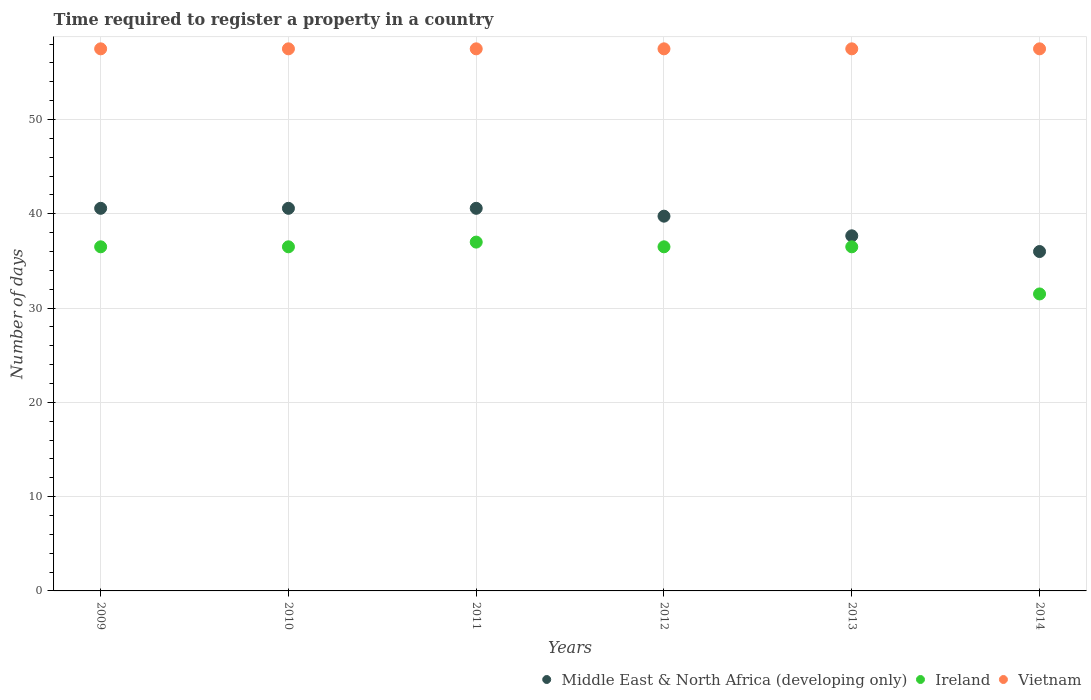Across all years, what is the maximum number of days required to register a property in Vietnam?
Your answer should be very brief. 57.5. Across all years, what is the minimum number of days required to register a property in Ireland?
Your answer should be very brief. 31.5. In which year was the number of days required to register a property in Middle East & North Africa (developing only) minimum?
Keep it short and to the point. 2014. What is the total number of days required to register a property in Vietnam in the graph?
Your answer should be very brief. 345. What is the difference between the number of days required to register a property in Middle East & North Africa (developing only) in 2009 and that in 2012?
Provide a succinct answer. 0.83. What is the difference between the number of days required to register a property in Ireland in 2011 and the number of days required to register a property in Middle East & North Africa (developing only) in 2014?
Ensure brevity in your answer.  1. What is the average number of days required to register a property in Middle East & North Africa (developing only) per year?
Your response must be concise. 39.19. In the year 2011, what is the difference between the number of days required to register a property in Vietnam and number of days required to register a property in Middle East & North Africa (developing only)?
Offer a very short reply. 16.92. Is the number of days required to register a property in Vietnam in 2009 less than that in 2013?
Provide a succinct answer. No. What is the difference between the highest and the second highest number of days required to register a property in Vietnam?
Give a very brief answer. 0. In how many years, is the number of days required to register a property in Ireland greater than the average number of days required to register a property in Ireland taken over all years?
Give a very brief answer. 5. Is the sum of the number of days required to register a property in Ireland in 2011 and 2013 greater than the maximum number of days required to register a property in Middle East & North Africa (developing only) across all years?
Offer a terse response. Yes. Is it the case that in every year, the sum of the number of days required to register a property in Ireland and number of days required to register a property in Vietnam  is greater than the number of days required to register a property in Middle East & North Africa (developing only)?
Give a very brief answer. Yes. Is the number of days required to register a property in Vietnam strictly greater than the number of days required to register a property in Middle East & North Africa (developing only) over the years?
Your answer should be very brief. Yes. Is the number of days required to register a property in Middle East & North Africa (developing only) strictly less than the number of days required to register a property in Ireland over the years?
Make the answer very short. No. How many dotlines are there?
Your answer should be compact. 3. How many years are there in the graph?
Make the answer very short. 6. Are the values on the major ticks of Y-axis written in scientific E-notation?
Your response must be concise. No. Does the graph contain any zero values?
Offer a very short reply. No. Where does the legend appear in the graph?
Offer a terse response. Bottom right. How are the legend labels stacked?
Provide a short and direct response. Horizontal. What is the title of the graph?
Provide a succinct answer. Time required to register a property in a country. Does "Indonesia" appear as one of the legend labels in the graph?
Provide a short and direct response. No. What is the label or title of the Y-axis?
Keep it short and to the point. Number of days. What is the Number of days of Middle East & North Africa (developing only) in 2009?
Offer a very short reply. 40.58. What is the Number of days of Ireland in 2009?
Provide a short and direct response. 36.5. What is the Number of days of Vietnam in 2009?
Give a very brief answer. 57.5. What is the Number of days in Middle East & North Africa (developing only) in 2010?
Your answer should be very brief. 40.58. What is the Number of days in Ireland in 2010?
Offer a very short reply. 36.5. What is the Number of days in Vietnam in 2010?
Your response must be concise. 57.5. What is the Number of days in Middle East & North Africa (developing only) in 2011?
Provide a succinct answer. 40.58. What is the Number of days of Ireland in 2011?
Ensure brevity in your answer.  37. What is the Number of days of Vietnam in 2011?
Offer a very short reply. 57.5. What is the Number of days in Middle East & North Africa (developing only) in 2012?
Offer a terse response. 39.75. What is the Number of days in Ireland in 2012?
Make the answer very short. 36.5. What is the Number of days of Vietnam in 2012?
Ensure brevity in your answer.  57.5. What is the Number of days in Middle East & North Africa (developing only) in 2013?
Keep it short and to the point. 37.67. What is the Number of days of Ireland in 2013?
Your response must be concise. 36.5. What is the Number of days in Vietnam in 2013?
Give a very brief answer. 57.5. What is the Number of days of Middle East & North Africa (developing only) in 2014?
Your answer should be compact. 36. What is the Number of days of Ireland in 2014?
Ensure brevity in your answer.  31.5. What is the Number of days in Vietnam in 2014?
Keep it short and to the point. 57.5. Across all years, what is the maximum Number of days in Middle East & North Africa (developing only)?
Offer a very short reply. 40.58. Across all years, what is the maximum Number of days of Vietnam?
Make the answer very short. 57.5. Across all years, what is the minimum Number of days of Middle East & North Africa (developing only)?
Your answer should be compact. 36. Across all years, what is the minimum Number of days in Ireland?
Your answer should be compact. 31.5. Across all years, what is the minimum Number of days in Vietnam?
Make the answer very short. 57.5. What is the total Number of days in Middle East & North Africa (developing only) in the graph?
Make the answer very short. 235.17. What is the total Number of days in Ireland in the graph?
Your answer should be compact. 214.5. What is the total Number of days in Vietnam in the graph?
Offer a very short reply. 345. What is the difference between the Number of days of Ireland in 2009 and that in 2010?
Your answer should be compact. 0. What is the difference between the Number of days of Vietnam in 2009 and that in 2010?
Provide a succinct answer. 0. What is the difference between the Number of days in Middle East & North Africa (developing only) in 2009 and that in 2011?
Your answer should be very brief. 0. What is the difference between the Number of days of Ireland in 2009 and that in 2011?
Make the answer very short. -0.5. What is the difference between the Number of days in Vietnam in 2009 and that in 2011?
Your answer should be compact. 0. What is the difference between the Number of days in Middle East & North Africa (developing only) in 2009 and that in 2012?
Offer a terse response. 0.83. What is the difference between the Number of days of Ireland in 2009 and that in 2012?
Keep it short and to the point. 0. What is the difference between the Number of days of Middle East & North Africa (developing only) in 2009 and that in 2013?
Offer a very short reply. 2.92. What is the difference between the Number of days of Ireland in 2009 and that in 2013?
Offer a terse response. 0. What is the difference between the Number of days in Middle East & North Africa (developing only) in 2009 and that in 2014?
Keep it short and to the point. 4.58. What is the difference between the Number of days in Ireland in 2009 and that in 2014?
Ensure brevity in your answer.  5. What is the difference between the Number of days of Vietnam in 2009 and that in 2014?
Provide a short and direct response. 0. What is the difference between the Number of days in Ireland in 2010 and that in 2011?
Your response must be concise. -0.5. What is the difference between the Number of days of Middle East & North Africa (developing only) in 2010 and that in 2012?
Provide a short and direct response. 0.83. What is the difference between the Number of days of Middle East & North Africa (developing only) in 2010 and that in 2013?
Offer a terse response. 2.92. What is the difference between the Number of days of Vietnam in 2010 and that in 2013?
Provide a succinct answer. 0. What is the difference between the Number of days in Middle East & North Africa (developing only) in 2010 and that in 2014?
Offer a very short reply. 4.58. What is the difference between the Number of days of Ireland in 2010 and that in 2014?
Make the answer very short. 5. What is the difference between the Number of days of Ireland in 2011 and that in 2012?
Your answer should be very brief. 0.5. What is the difference between the Number of days in Middle East & North Africa (developing only) in 2011 and that in 2013?
Your answer should be compact. 2.92. What is the difference between the Number of days in Ireland in 2011 and that in 2013?
Your response must be concise. 0.5. What is the difference between the Number of days in Middle East & North Africa (developing only) in 2011 and that in 2014?
Your answer should be compact. 4.58. What is the difference between the Number of days in Vietnam in 2011 and that in 2014?
Give a very brief answer. 0. What is the difference between the Number of days of Middle East & North Africa (developing only) in 2012 and that in 2013?
Keep it short and to the point. 2.08. What is the difference between the Number of days of Middle East & North Africa (developing only) in 2012 and that in 2014?
Your answer should be very brief. 3.75. What is the difference between the Number of days of Ireland in 2012 and that in 2014?
Provide a succinct answer. 5. What is the difference between the Number of days of Vietnam in 2012 and that in 2014?
Ensure brevity in your answer.  0. What is the difference between the Number of days of Vietnam in 2013 and that in 2014?
Provide a succinct answer. 0. What is the difference between the Number of days in Middle East & North Africa (developing only) in 2009 and the Number of days in Ireland in 2010?
Your answer should be very brief. 4.08. What is the difference between the Number of days of Middle East & North Africa (developing only) in 2009 and the Number of days of Vietnam in 2010?
Your answer should be very brief. -16.92. What is the difference between the Number of days of Ireland in 2009 and the Number of days of Vietnam in 2010?
Provide a short and direct response. -21. What is the difference between the Number of days of Middle East & North Africa (developing only) in 2009 and the Number of days of Ireland in 2011?
Your answer should be very brief. 3.58. What is the difference between the Number of days of Middle East & North Africa (developing only) in 2009 and the Number of days of Vietnam in 2011?
Provide a short and direct response. -16.92. What is the difference between the Number of days of Middle East & North Africa (developing only) in 2009 and the Number of days of Ireland in 2012?
Give a very brief answer. 4.08. What is the difference between the Number of days in Middle East & North Africa (developing only) in 2009 and the Number of days in Vietnam in 2012?
Ensure brevity in your answer.  -16.92. What is the difference between the Number of days of Middle East & North Africa (developing only) in 2009 and the Number of days of Ireland in 2013?
Provide a short and direct response. 4.08. What is the difference between the Number of days in Middle East & North Africa (developing only) in 2009 and the Number of days in Vietnam in 2013?
Your response must be concise. -16.92. What is the difference between the Number of days in Ireland in 2009 and the Number of days in Vietnam in 2013?
Offer a very short reply. -21. What is the difference between the Number of days of Middle East & North Africa (developing only) in 2009 and the Number of days of Ireland in 2014?
Offer a terse response. 9.08. What is the difference between the Number of days of Middle East & North Africa (developing only) in 2009 and the Number of days of Vietnam in 2014?
Give a very brief answer. -16.92. What is the difference between the Number of days in Ireland in 2009 and the Number of days in Vietnam in 2014?
Your response must be concise. -21. What is the difference between the Number of days of Middle East & North Africa (developing only) in 2010 and the Number of days of Ireland in 2011?
Your response must be concise. 3.58. What is the difference between the Number of days of Middle East & North Africa (developing only) in 2010 and the Number of days of Vietnam in 2011?
Your answer should be compact. -16.92. What is the difference between the Number of days of Middle East & North Africa (developing only) in 2010 and the Number of days of Ireland in 2012?
Your answer should be very brief. 4.08. What is the difference between the Number of days in Middle East & North Africa (developing only) in 2010 and the Number of days in Vietnam in 2012?
Your answer should be compact. -16.92. What is the difference between the Number of days of Middle East & North Africa (developing only) in 2010 and the Number of days of Ireland in 2013?
Give a very brief answer. 4.08. What is the difference between the Number of days of Middle East & North Africa (developing only) in 2010 and the Number of days of Vietnam in 2013?
Make the answer very short. -16.92. What is the difference between the Number of days in Middle East & North Africa (developing only) in 2010 and the Number of days in Ireland in 2014?
Provide a succinct answer. 9.08. What is the difference between the Number of days of Middle East & North Africa (developing only) in 2010 and the Number of days of Vietnam in 2014?
Offer a terse response. -16.92. What is the difference between the Number of days of Middle East & North Africa (developing only) in 2011 and the Number of days of Ireland in 2012?
Ensure brevity in your answer.  4.08. What is the difference between the Number of days in Middle East & North Africa (developing only) in 2011 and the Number of days in Vietnam in 2012?
Offer a terse response. -16.92. What is the difference between the Number of days of Ireland in 2011 and the Number of days of Vietnam in 2012?
Your answer should be very brief. -20.5. What is the difference between the Number of days in Middle East & North Africa (developing only) in 2011 and the Number of days in Ireland in 2013?
Give a very brief answer. 4.08. What is the difference between the Number of days of Middle East & North Africa (developing only) in 2011 and the Number of days of Vietnam in 2013?
Ensure brevity in your answer.  -16.92. What is the difference between the Number of days in Ireland in 2011 and the Number of days in Vietnam in 2013?
Provide a short and direct response. -20.5. What is the difference between the Number of days in Middle East & North Africa (developing only) in 2011 and the Number of days in Ireland in 2014?
Keep it short and to the point. 9.08. What is the difference between the Number of days in Middle East & North Africa (developing only) in 2011 and the Number of days in Vietnam in 2014?
Offer a very short reply. -16.92. What is the difference between the Number of days in Ireland in 2011 and the Number of days in Vietnam in 2014?
Your answer should be compact. -20.5. What is the difference between the Number of days of Middle East & North Africa (developing only) in 2012 and the Number of days of Vietnam in 2013?
Offer a terse response. -17.75. What is the difference between the Number of days of Middle East & North Africa (developing only) in 2012 and the Number of days of Ireland in 2014?
Your answer should be very brief. 8.25. What is the difference between the Number of days of Middle East & North Africa (developing only) in 2012 and the Number of days of Vietnam in 2014?
Give a very brief answer. -17.75. What is the difference between the Number of days of Middle East & North Africa (developing only) in 2013 and the Number of days of Ireland in 2014?
Your answer should be very brief. 6.17. What is the difference between the Number of days of Middle East & North Africa (developing only) in 2013 and the Number of days of Vietnam in 2014?
Provide a short and direct response. -19.83. What is the difference between the Number of days in Ireland in 2013 and the Number of days in Vietnam in 2014?
Provide a succinct answer. -21. What is the average Number of days in Middle East & North Africa (developing only) per year?
Make the answer very short. 39.19. What is the average Number of days of Ireland per year?
Your response must be concise. 35.75. What is the average Number of days in Vietnam per year?
Offer a terse response. 57.5. In the year 2009, what is the difference between the Number of days of Middle East & North Africa (developing only) and Number of days of Ireland?
Your response must be concise. 4.08. In the year 2009, what is the difference between the Number of days in Middle East & North Africa (developing only) and Number of days in Vietnam?
Offer a very short reply. -16.92. In the year 2010, what is the difference between the Number of days in Middle East & North Africa (developing only) and Number of days in Ireland?
Your answer should be very brief. 4.08. In the year 2010, what is the difference between the Number of days of Middle East & North Africa (developing only) and Number of days of Vietnam?
Your response must be concise. -16.92. In the year 2010, what is the difference between the Number of days of Ireland and Number of days of Vietnam?
Make the answer very short. -21. In the year 2011, what is the difference between the Number of days in Middle East & North Africa (developing only) and Number of days in Ireland?
Keep it short and to the point. 3.58. In the year 2011, what is the difference between the Number of days of Middle East & North Africa (developing only) and Number of days of Vietnam?
Provide a short and direct response. -16.92. In the year 2011, what is the difference between the Number of days of Ireland and Number of days of Vietnam?
Keep it short and to the point. -20.5. In the year 2012, what is the difference between the Number of days of Middle East & North Africa (developing only) and Number of days of Ireland?
Give a very brief answer. 3.25. In the year 2012, what is the difference between the Number of days in Middle East & North Africa (developing only) and Number of days in Vietnam?
Offer a terse response. -17.75. In the year 2012, what is the difference between the Number of days of Ireland and Number of days of Vietnam?
Keep it short and to the point. -21. In the year 2013, what is the difference between the Number of days of Middle East & North Africa (developing only) and Number of days of Ireland?
Offer a very short reply. 1.17. In the year 2013, what is the difference between the Number of days of Middle East & North Africa (developing only) and Number of days of Vietnam?
Offer a very short reply. -19.83. In the year 2013, what is the difference between the Number of days in Ireland and Number of days in Vietnam?
Keep it short and to the point. -21. In the year 2014, what is the difference between the Number of days of Middle East & North Africa (developing only) and Number of days of Ireland?
Provide a succinct answer. 4.5. In the year 2014, what is the difference between the Number of days in Middle East & North Africa (developing only) and Number of days in Vietnam?
Ensure brevity in your answer.  -21.5. In the year 2014, what is the difference between the Number of days of Ireland and Number of days of Vietnam?
Make the answer very short. -26. What is the ratio of the Number of days in Middle East & North Africa (developing only) in 2009 to that in 2010?
Your response must be concise. 1. What is the ratio of the Number of days of Ireland in 2009 to that in 2010?
Provide a succinct answer. 1. What is the ratio of the Number of days in Ireland in 2009 to that in 2011?
Provide a short and direct response. 0.99. What is the ratio of the Number of days in Middle East & North Africa (developing only) in 2009 to that in 2012?
Provide a succinct answer. 1.02. What is the ratio of the Number of days in Ireland in 2009 to that in 2012?
Provide a short and direct response. 1. What is the ratio of the Number of days in Middle East & North Africa (developing only) in 2009 to that in 2013?
Provide a succinct answer. 1.08. What is the ratio of the Number of days of Ireland in 2009 to that in 2013?
Ensure brevity in your answer.  1. What is the ratio of the Number of days of Middle East & North Africa (developing only) in 2009 to that in 2014?
Keep it short and to the point. 1.13. What is the ratio of the Number of days in Ireland in 2009 to that in 2014?
Provide a short and direct response. 1.16. What is the ratio of the Number of days of Vietnam in 2009 to that in 2014?
Keep it short and to the point. 1. What is the ratio of the Number of days of Middle East & North Africa (developing only) in 2010 to that in 2011?
Your answer should be very brief. 1. What is the ratio of the Number of days in Ireland in 2010 to that in 2011?
Provide a succinct answer. 0.99. What is the ratio of the Number of days of Vietnam in 2010 to that in 2011?
Give a very brief answer. 1. What is the ratio of the Number of days in Ireland in 2010 to that in 2012?
Offer a terse response. 1. What is the ratio of the Number of days of Middle East & North Africa (developing only) in 2010 to that in 2013?
Ensure brevity in your answer.  1.08. What is the ratio of the Number of days in Ireland in 2010 to that in 2013?
Offer a very short reply. 1. What is the ratio of the Number of days of Vietnam in 2010 to that in 2013?
Your answer should be compact. 1. What is the ratio of the Number of days in Middle East & North Africa (developing only) in 2010 to that in 2014?
Offer a terse response. 1.13. What is the ratio of the Number of days in Ireland in 2010 to that in 2014?
Your answer should be compact. 1.16. What is the ratio of the Number of days of Ireland in 2011 to that in 2012?
Your answer should be very brief. 1.01. What is the ratio of the Number of days of Middle East & North Africa (developing only) in 2011 to that in 2013?
Your answer should be compact. 1.08. What is the ratio of the Number of days in Ireland in 2011 to that in 2013?
Give a very brief answer. 1.01. What is the ratio of the Number of days of Vietnam in 2011 to that in 2013?
Your response must be concise. 1. What is the ratio of the Number of days of Middle East & North Africa (developing only) in 2011 to that in 2014?
Provide a short and direct response. 1.13. What is the ratio of the Number of days in Ireland in 2011 to that in 2014?
Your answer should be very brief. 1.17. What is the ratio of the Number of days in Vietnam in 2011 to that in 2014?
Your answer should be compact. 1. What is the ratio of the Number of days in Middle East & North Africa (developing only) in 2012 to that in 2013?
Ensure brevity in your answer.  1.06. What is the ratio of the Number of days in Middle East & North Africa (developing only) in 2012 to that in 2014?
Keep it short and to the point. 1.1. What is the ratio of the Number of days of Ireland in 2012 to that in 2014?
Your answer should be very brief. 1.16. What is the ratio of the Number of days of Middle East & North Africa (developing only) in 2013 to that in 2014?
Your answer should be very brief. 1.05. What is the ratio of the Number of days in Ireland in 2013 to that in 2014?
Your answer should be compact. 1.16. What is the ratio of the Number of days in Vietnam in 2013 to that in 2014?
Offer a very short reply. 1. What is the difference between the highest and the second highest Number of days in Ireland?
Keep it short and to the point. 0.5. What is the difference between the highest and the second highest Number of days of Vietnam?
Give a very brief answer. 0. What is the difference between the highest and the lowest Number of days of Middle East & North Africa (developing only)?
Your response must be concise. 4.58. What is the difference between the highest and the lowest Number of days in Ireland?
Offer a very short reply. 5.5. 